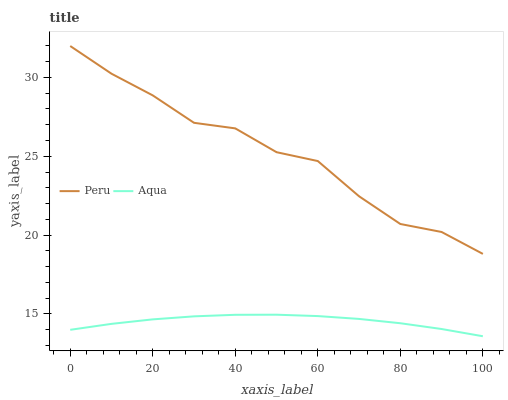Does Aqua have the minimum area under the curve?
Answer yes or no. Yes. Does Peru have the maximum area under the curve?
Answer yes or no. Yes. Does Peru have the minimum area under the curve?
Answer yes or no. No. Is Aqua the smoothest?
Answer yes or no. Yes. Is Peru the roughest?
Answer yes or no. Yes. Is Peru the smoothest?
Answer yes or no. No. Does Aqua have the lowest value?
Answer yes or no. Yes. Does Peru have the lowest value?
Answer yes or no. No. Does Peru have the highest value?
Answer yes or no. Yes. Is Aqua less than Peru?
Answer yes or no. Yes. Is Peru greater than Aqua?
Answer yes or no. Yes. Does Aqua intersect Peru?
Answer yes or no. No. 